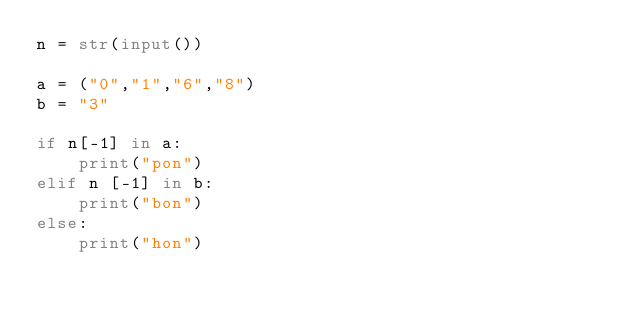Convert code to text. <code><loc_0><loc_0><loc_500><loc_500><_Python_>n = str(input())

a = ("0","1","6","8")
b = "3"

if n[-1] in a:
    print("pon")
elif n [-1] in b:
    print("bon")
else:
    print("hon")
</code> 